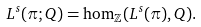Convert formula to latex. <formula><loc_0><loc_0><loc_500><loc_500>L ^ { s } ( \pi ; Q ) & = \hom _ { \mathbb { Z } } ( L ^ { s } ( \pi ) , Q ) .</formula> 